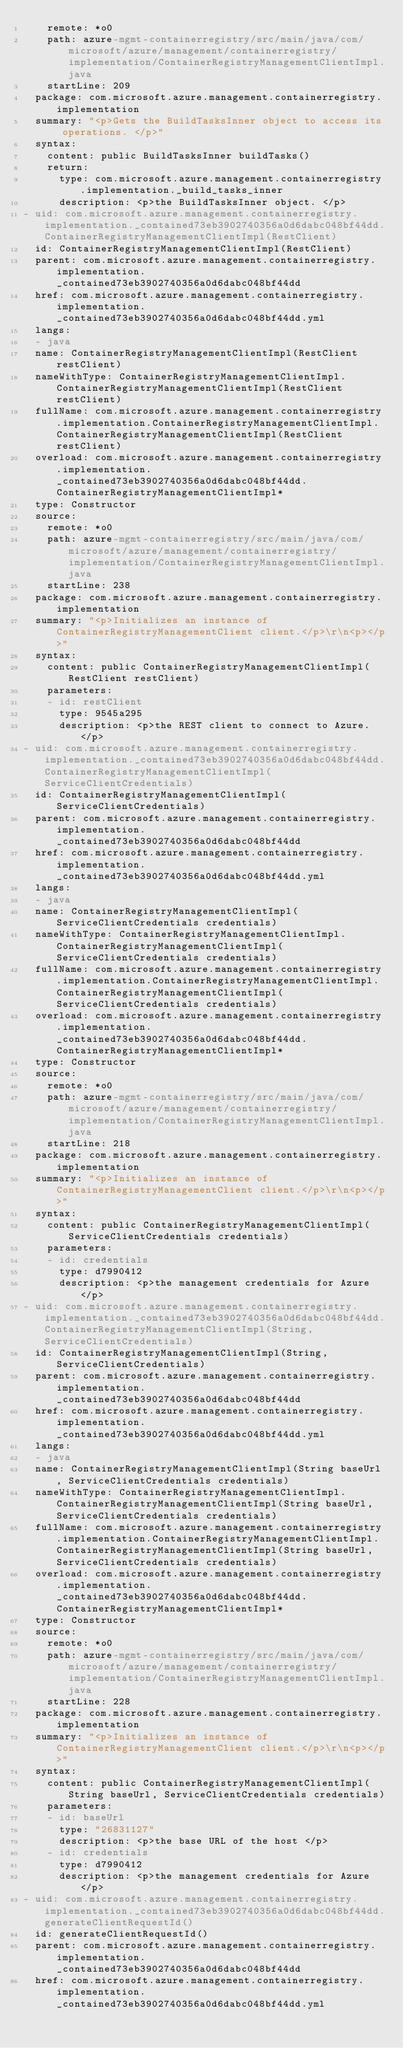Convert code to text. <code><loc_0><loc_0><loc_500><loc_500><_YAML_>    remote: *o0
    path: azure-mgmt-containerregistry/src/main/java/com/microsoft/azure/management/containerregistry/implementation/ContainerRegistryManagementClientImpl.java
    startLine: 209
  package: com.microsoft.azure.management.containerregistry.implementation
  summary: "<p>Gets the BuildTasksInner object to access its operations. </p>"
  syntax:
    content: public BuildTasksInner buildTasks()
    return:
      type: com.microsoft.azure.management.containerregistry.implementation._build_tasks_inner
      description: <p>the BuildTasksInner object. </p>
- uid: com.microsoft.azure.management.containerregistry.implementation._contained73eb3902740356a0d6dabc048bf44dd.ContainerRegistryManagementClientImpl(RestClient)
  id: ContainerRegistryManagementClientImpl(RestClient)
  parent: com.microsoft.azure.management.containerregistry.implementation._contained73eb3902740356a0d6dabc048bf44dd
  href: com.microsoft.azure.management.containerregistry.implementation._contained73eb3902740356a0d6dabc048bf44dd.yml
  langs:
  - java
  name: ContainerRegistryManagementClientImpl(RestClient restClient)
  nameWithType: ContainerRegistryManagementClientImpl.ContainerRegistryManagementClientImpl(RestClient restClient)
  fullName: com.microsoft.azure.management.containerregistry.implementation.ContainerRegistryManagementClientImpl.ContainerRegistryManagementClientImpl(RestClient restClient)
  overload: com.microsoft.azure.management.containerregistry.implementation._contained73eb3902740356a0d6dabc048bf44dd.ContainerRegistryManagementClientImpl*
  type: Constructor
  source:
    remote: *o0
    path: azure-mgmt-containerregistry/src/main/java/com/microsoft/azure/management/containerregistry/implementation/ContainerRegistryManagementClientImpl.java
    startLine: 238
  package: com.microsoft.azure.management.containerregistry.implementation
  summary: "<p>Initializes an instance of ContainerRegistryManagementClient client.</p>\r\n<p></p>"
  syntax:
    content: public ContainerRegistryManagementClientImpl(RestClient restClient)
    parameters:
    - id: restClient
      type: 9545a295
      description: <p>the REST client to connect to Azure. </p>
- uid: com.microsoft.azure.management.containerregistry.implementation._contained73eb3902740356a0d6dabc048bf44dd.ContainerRegistryManagementClientImpl(ServiceClientCredentials)
  id: ContainerRegistryManagementClientImpl(ServiceClientCredentials)
  parent: com.microsoft.azure.management.containerregistry.implementation._contained73eb3902740356a0d6dabc048bf44dd
  href: com.microsoft.azure.management.containerregistry.implementation._contained73eb3902740356a0d6dabc048bf44dd.yml
  langs:
  - java
  name: ContainerRegistryManagementClientImpl(ServiceClientCredentials credentials)
  nameWithType: ContainerRegistryManagementClientImpl.ContainerRegistryManagementClientImpl(ServiceClientCredentials credentials)
  fullName: com.microsoft.azure.management.containerregistry.implementation.ContainerRegistryManagementClientImpl.ContainerRegistryManagementClientImpl(ServiceClientCredentials credentials)
  overload: com.microsoft.azure.management.containerregistry.implementation._contained73eb3902740356a0d6dabc048bf44dd.ContainerRegistryManagementClientImpl*
  type: Constructor
  source:
    remote: *o0
    path: azure-mgmt-containerregistry/src/main/java/com/microsoft/azure/management/containerregistry/implementation/ContainerRegistryManagementClientImpl.java
    startLine: 218
  package: com.microsoft.azure.management.containerregistry.implementation
  summary: "<p>Initializes an instance of ContainerRegistryManagementClient client.</p>\r\n<p></p>"
  syntax:
    content: public ContainerRegistryManagementClientImpl(ServiceClientCredentials credentials)
    parameters:
    - id: credentials
      type: d7990412
      description: <p>the management credentials for Azure </p>
- uid: com.microsoft.azure.management.containerregistry.implementation._contained73eb3902740356a0d6dabc048bf44dd.ContainerRegistryManagementClientImpl(String,ServiceClientCredentials)
  id: ContainerRegistryManagementClientImpl(String,ServiceClientCredentials)
  parent: com.microsoft.azure.management.containerregistry.implementation._contained73eb3902740356a0d6dabc048bf44dd
  href: com.microsoft.azure.management.containerregistry.implementation._contained73eb3902740356a0d6dabc048bf44dd.yml
  langs:
  - java
  name: ContainerRegistryManagementClientImpl(String baseUrl, ServiceClientCredentials credentials)
  nameWithType: ContainerRegistryManagementClientImpl.ContainerRegistryManagementClientImpl(String baseUrl, ServiceClientCredentials credentials)
  fullName: com.microsoft.azure.management.containerregistry.implementation.ContainerRegistryManagementClientImpl.ContainerRegistryManagementClientImpl(String baseUrl, ServiceClientCredentials credentials)
  overload: com.microsoft.azure.management.containerregistry.implementation._contained73eb3902740356a0d6dabc048bf44dd.ContainerRegistryManagementClientImpl*
  type: Constructor
  source:
    remote: *o0
    path: azure-mgmt-containerregistry/src/main/java/com/microsoft/azure/management/containerregistry/implementation/ContainerRegistryManagementClientImpl.java
    startLine: 228
  package: com.microsoft.azure.management.containerregistry.implementation
  summary: "<p>Initializes an instance of ContainerRegistryManagementClient client.</p>\r\n<p></p>"
  syntax:
    content: public ContainerRegistryManagementClientImpl(String baseUrl, ServiceClientCredentials credentials)
    parameters:
    - id: baseUrl
      type: "26831127"
      description: <p>the base URL of the host </p>
    - id: credentials
      type: d7990412
      description: <p>the management credentials for Azure </p>
- uid: com.microsoft.azure.management.containerregistry.implementation._contained73eb3902740356a0d6dabc048bf44dd.generateClientRequestId()
  id: generateClientRequestId()
  parent: com.microsoft.azure.management.containerregistry.implementation._contained73eb3902740356a0d6dabc048bf44dd
  href: com.microsoft.azure.management.containerregistry.implementation._contained73eb3902740356a0d6dabc048bf44dd.yml</code> 